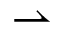Convert formula to latex. <formula><loc_0><loc_0><loc_500><loc_500>\rightharpoonup</formula> 